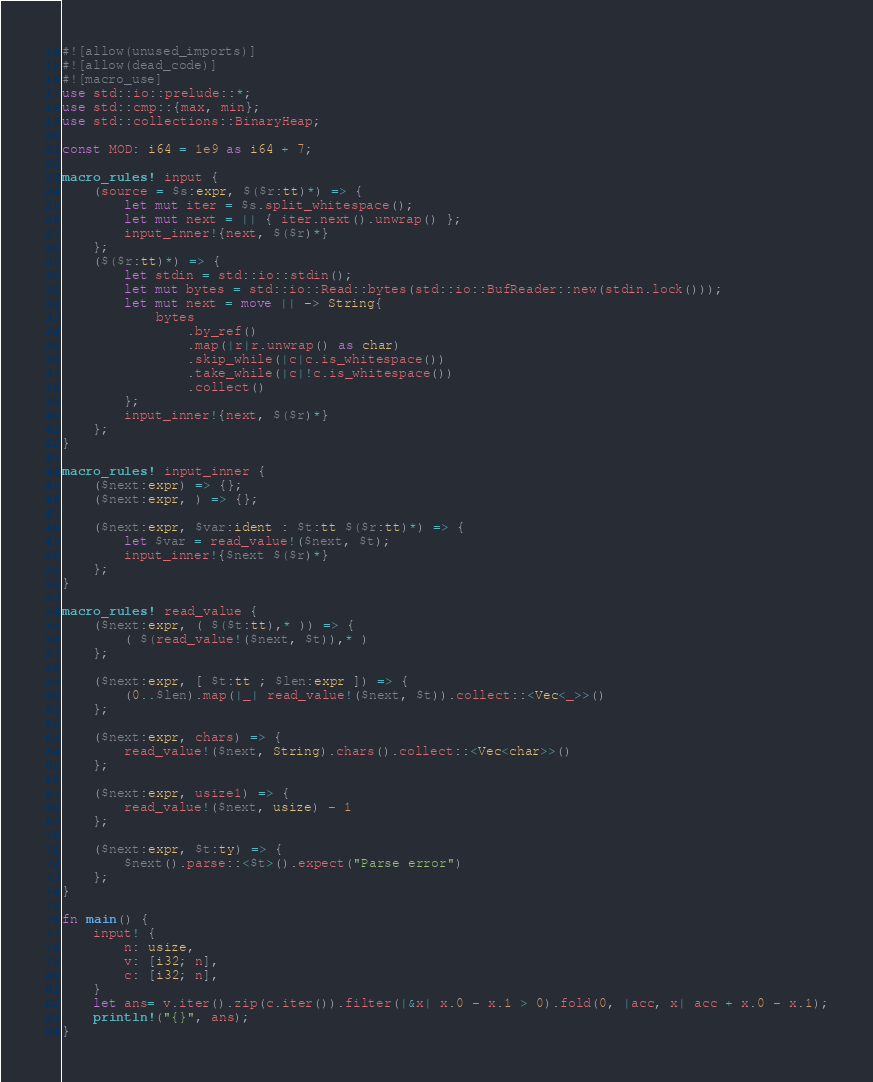<code> <loc_0><loc_0><loc_500><loc_500><_Rust_>#![allow(unused_imports)]
#![allow(dead_code)]
#![macro_use]
use std::io::prelude::*;
use std::cmp::{max, min};
use std::collections::BinaryHeap;

const MOD: i64 = 1e9 as i64 + 7;

macro_rules! input {
    (source = $s:expr, $($r:tt)*) => {
        let mut iter = $s.split_whitespace();
        let mut next = || { iter.next().unwrap() };
        input_inner!{next, $($r)*}
    };
    ($($r:tt)*) => {
        let stdin = std::io::stdin();
        let mut bytes = std::io::Read::bytes(std::io::BufReader::new(stdin.lock()));
        let mut next = move || -> String{
            bytes
                .by_ref()
                .map(|r|r.unwrap() as char)
                .skip_while(|c|c.is_whitespace())
                .take_while(|c|!c.is_whitespace())
                .collect()
        };
        input_inner!{next, $($r)*}
    };
}

macro_rules! input_inner {
    ($next:expr) => {};
    ($next:expr, ) => {};

    ($next:expr, $var:ident : $t:tt $($r:tt)*) => {
        let $var = read_value!($next, $t);
        input_inner!{$next $($r)*}
    };
}

macro_rules! read_value {
    ($next:expr, ( $($t:tt),* )) => {
        ( $(read_value!($next, $t)),* )
    };

    ($next:expr, [ $t:tt ; $len:expr ]) => {
        (0..$len).map(|_| read_value!($next, $t)).collect::<Vec<_>>()
    };

    ($next:expr, chars) => {
        read_value!($next, String).chars().collect::<Vec<char>>()
    };

    ($next:expr, usize1) => {
        read_value!($next, usize) - 1
    };

    ($next:expr, $t:ty) => {
        $next().parse::<$t>().expect("Parse error")
    };
}

fn main() {
    input! {
        n: usize,
        v: [i32; n],
        c: [i32; n],
    }
    let ans= v.iter().zip(c.iter()).filter(|&x| x.0 - x.1 > 0).fold(0, |acc, x| acc + x.0 - x.1);
    println!("{}", ans);
}
</code> 